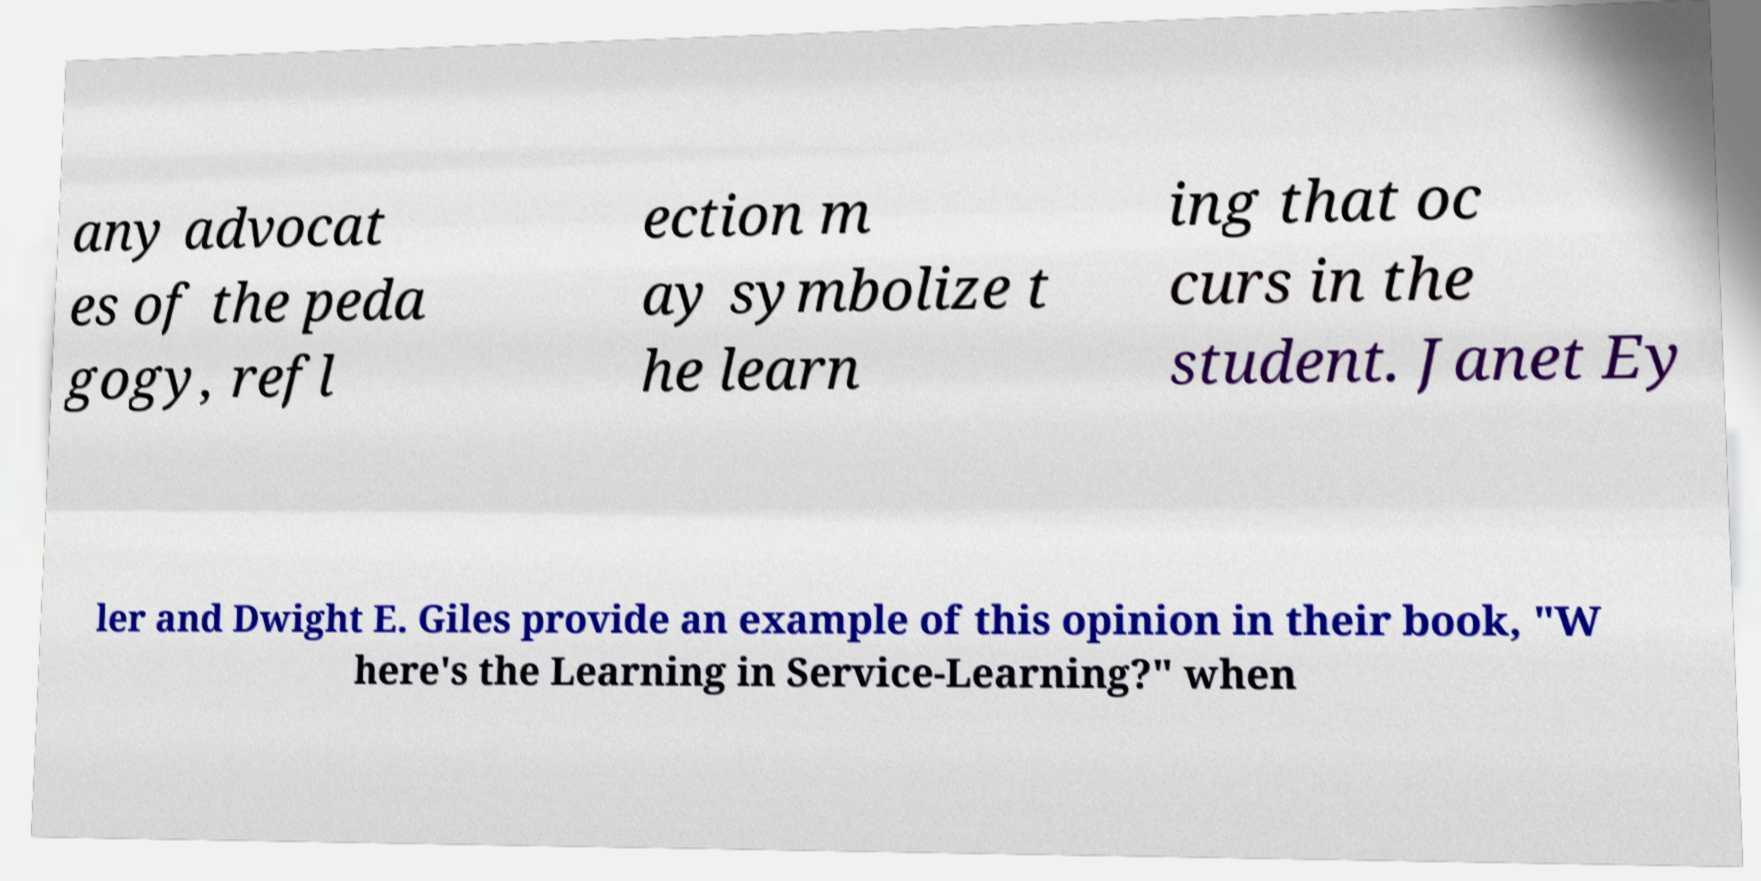Please identify and transcribe the text found in this image. any advocat es of the peda gogy, refl ection m ay symbolize t he learn ing that oc curs in the student. Janet Ey ler and Dwight E. Giles provide an example of this opinion in their book, "W here's the Learning in Service-Learning?" when 